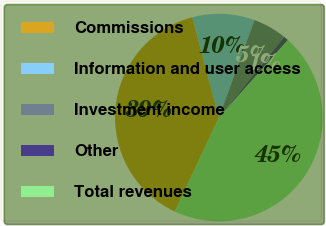Convert chart. <chart><loc_0><loc_0><loc_500><loc_500><pie_chart><fcel>Commissions<fcel>Information and user access<fcel>Investment income<fcel>Other<fcel>Total revenues<nl><fcel>38.9%<fcel>9.7%<fcel>5.23%<fcel>0.77%<fcel>45.39%<nl></chart> 